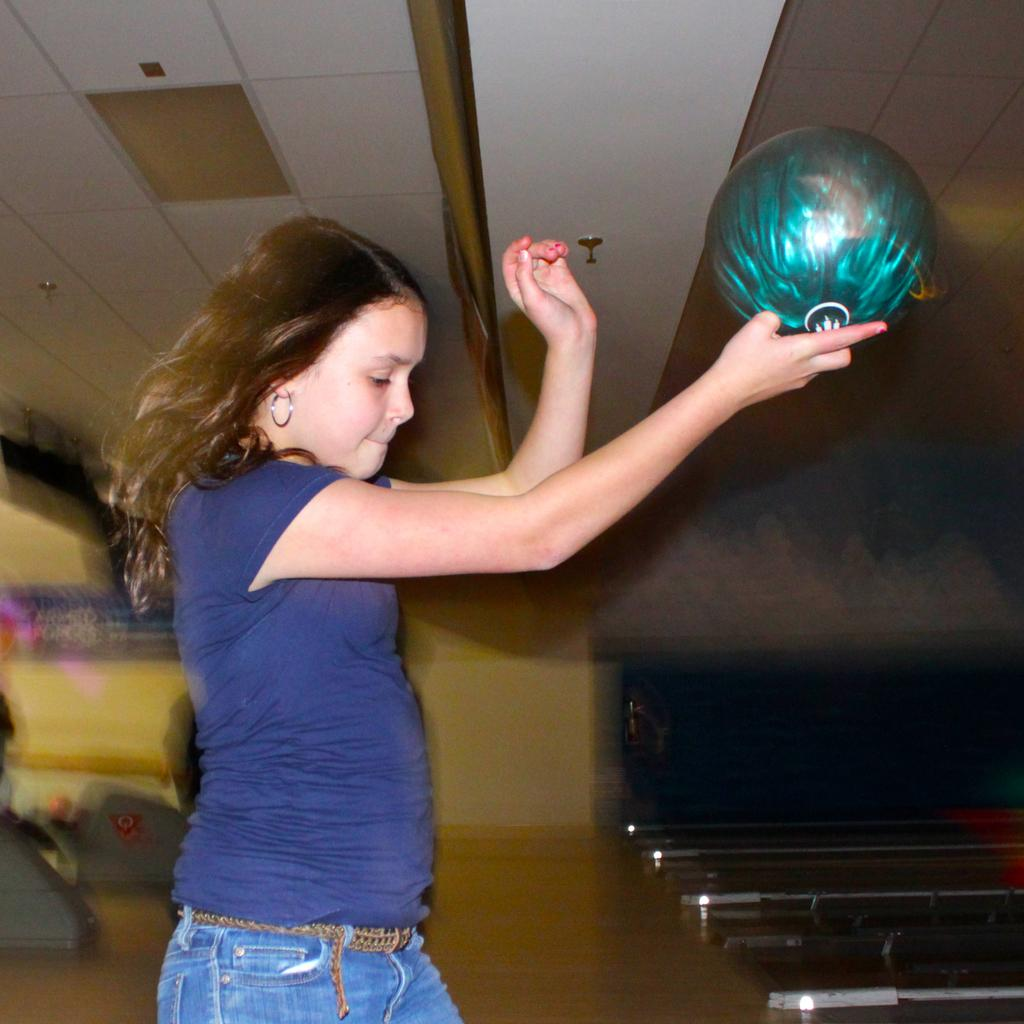Who is the main subject in the image? There is a girl in the image. What is the girl holding in the image? The girl is holding a green ball. Where is the girl standing in the image? The girl is standing on a bowling floor. What can be seen on the ceiling in the image? There are lights on the ceiling in the image. What statement does the actor make while sitting at the desk in the image? There is no actor or desk present in the image; it features a girl holding a green ball and standing on a bowling floor. 